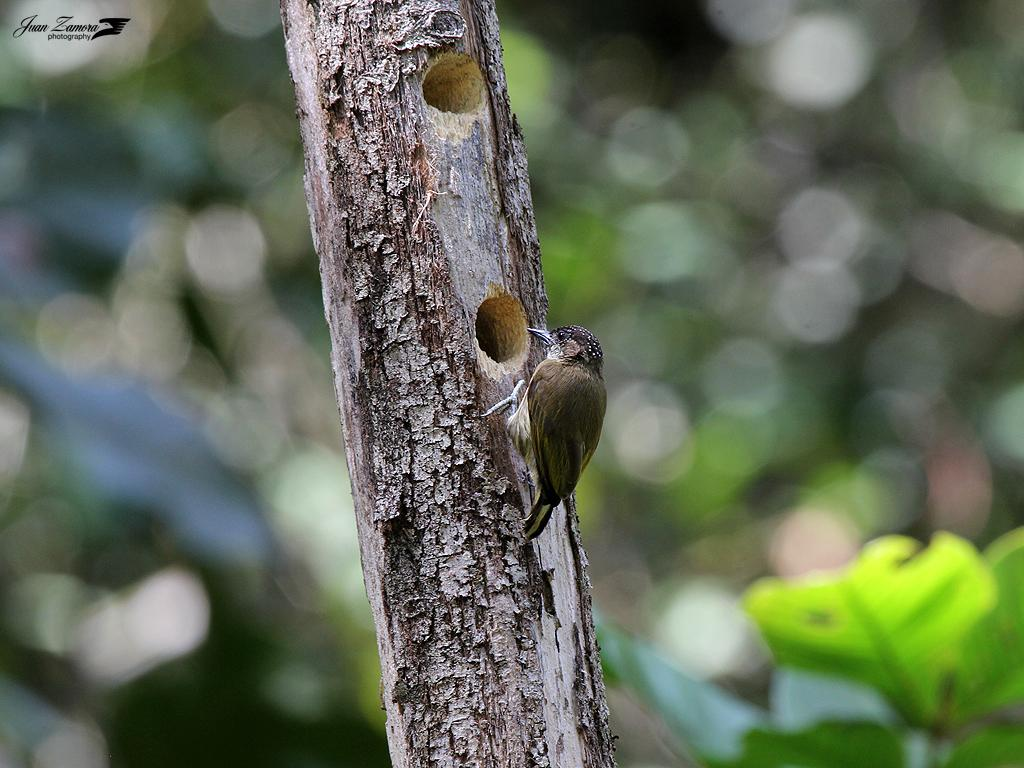What type of animal can be seen in the image? There is a bird in the image. Where is the bird located? The bird is on the branch of a tree. Can you describe the background of the image? The background of the image is blurred. Can you tell me how the bird is swimming in the image? There is no swimming activity depicted in the image; the bird is perched on a tree branch. 